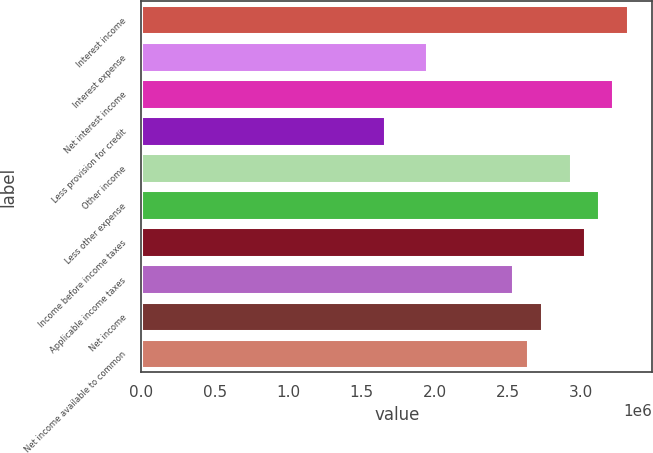Convert chart to OTSL. <chart><loc_0><loc_0><loc_500><loc_500><bar_chart><fcel>Interest income<fcel>Interest expense<fcel>Net interest income<fcel>Less provision for credit<fcel>Other income<fcel>Less other expense<fcel>Income before income taxes<fcel>Applicable income taxes<fcel>Net income<fcel>Net income available to common<nl><fcel>3.31921e+06<fcel>1.95248e+06<fcel>3.22159e+06<fcel>1.65961e+06<fcel>2.92872e+06<fcel>3.12397e+06<fcel>3.02634e+06<fcel>2.53822e+06<fcel>2.73347e+06<fcel>2.63585e+06<nl></chart> 